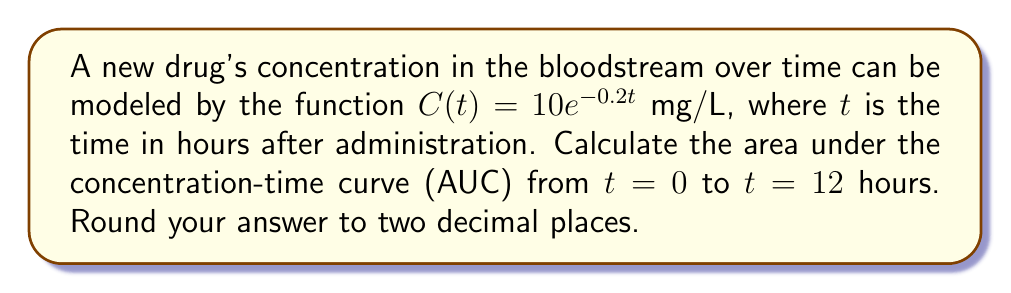Can you solve this math problem? To determine the area under the drug concentration curve, we need to integrate the function $C(t)$ from $t=0$ to $t=12$. Here's the step-by-step process:

1) The integral we need to evaluate is:
   $$\int_0^{12} 10e^{-0.2t} dt$$

2) To integrate this, we can use the rule for integrating exponential functions:
   $$\int e^{ax} dx = \frac{1}{a}e^{ax} + C$$

3) In our case, $a = -0.2$ and we have a constant factor of 10:
   $$10 \int_0^{12} e^{-0.2t} dt = 10 \cdot \left[-\frac{1}{0.2}e^{-0.2t}\right]_0^{12}$$

4) Evaluating the integral:
   $$= 10 \cdot \left(-5e^{-0.2t}\right)\Big|_0^{12}$$
   $$= 10 \cdot \left(-5e^{-0.2(12)} - (-5e^{-0.2(0)})\right)$$
   $$= 10 \cdot \left(-5e^{-2.4} + 5\right)$$

5) Simplifying:
   $$= 10 \cdot \left(5 - 5e^{-2.4}\right)$$
   $$= 50 - 50e^{-2.4}$$

6) Evaluating this expression:
   $$\approx 50 - 50 \cdot 0.0907$$
   $$\approx 50 - 4.535$$
   $$\approx 45.465$$

7) Rounding to two decimal places:
   $$\approx 45.47$$

Therefore, the area under the concentration-time curve from $t=0$ to $t=12$ hours is approximately 45.47 mg·h/L.
Answer: 45.47 mg·h/L 